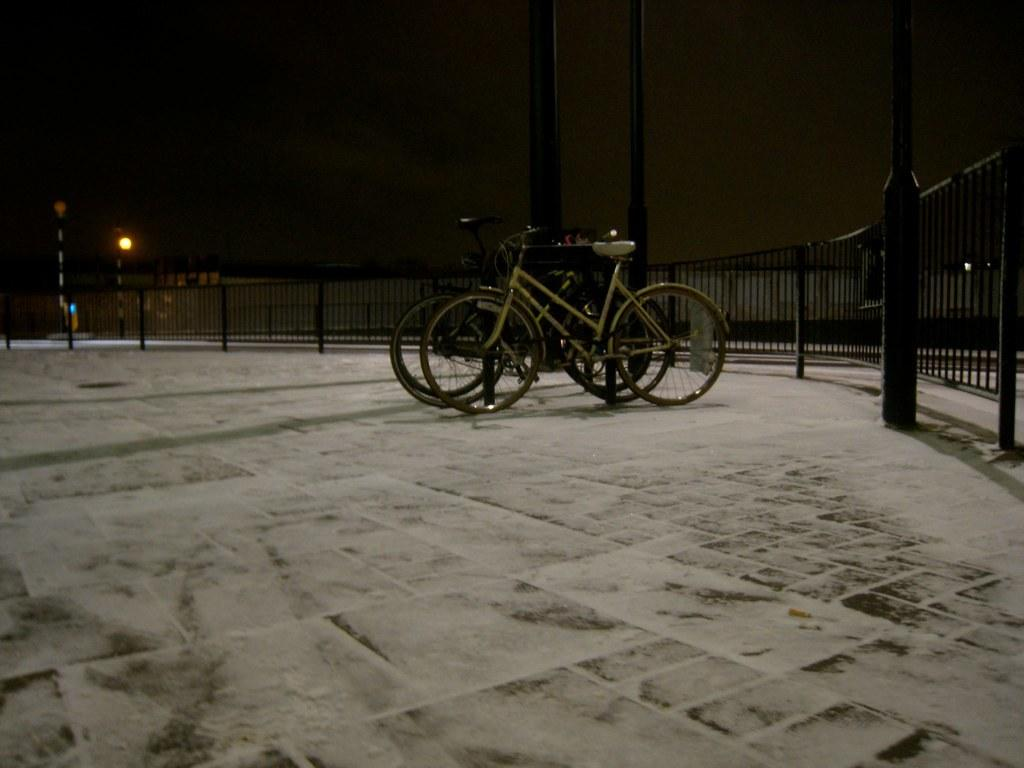What is the main subject in the center of the image? There are bicycles in the center of the image. What can be seen on the right side and background of the image? There are poles and iron fencing in the right side and background of the image. Where is the light located in the image? The light is on the left side of the image. What type of pen is being used by the achiever in the image? There is no achiever or pen present in the image. 